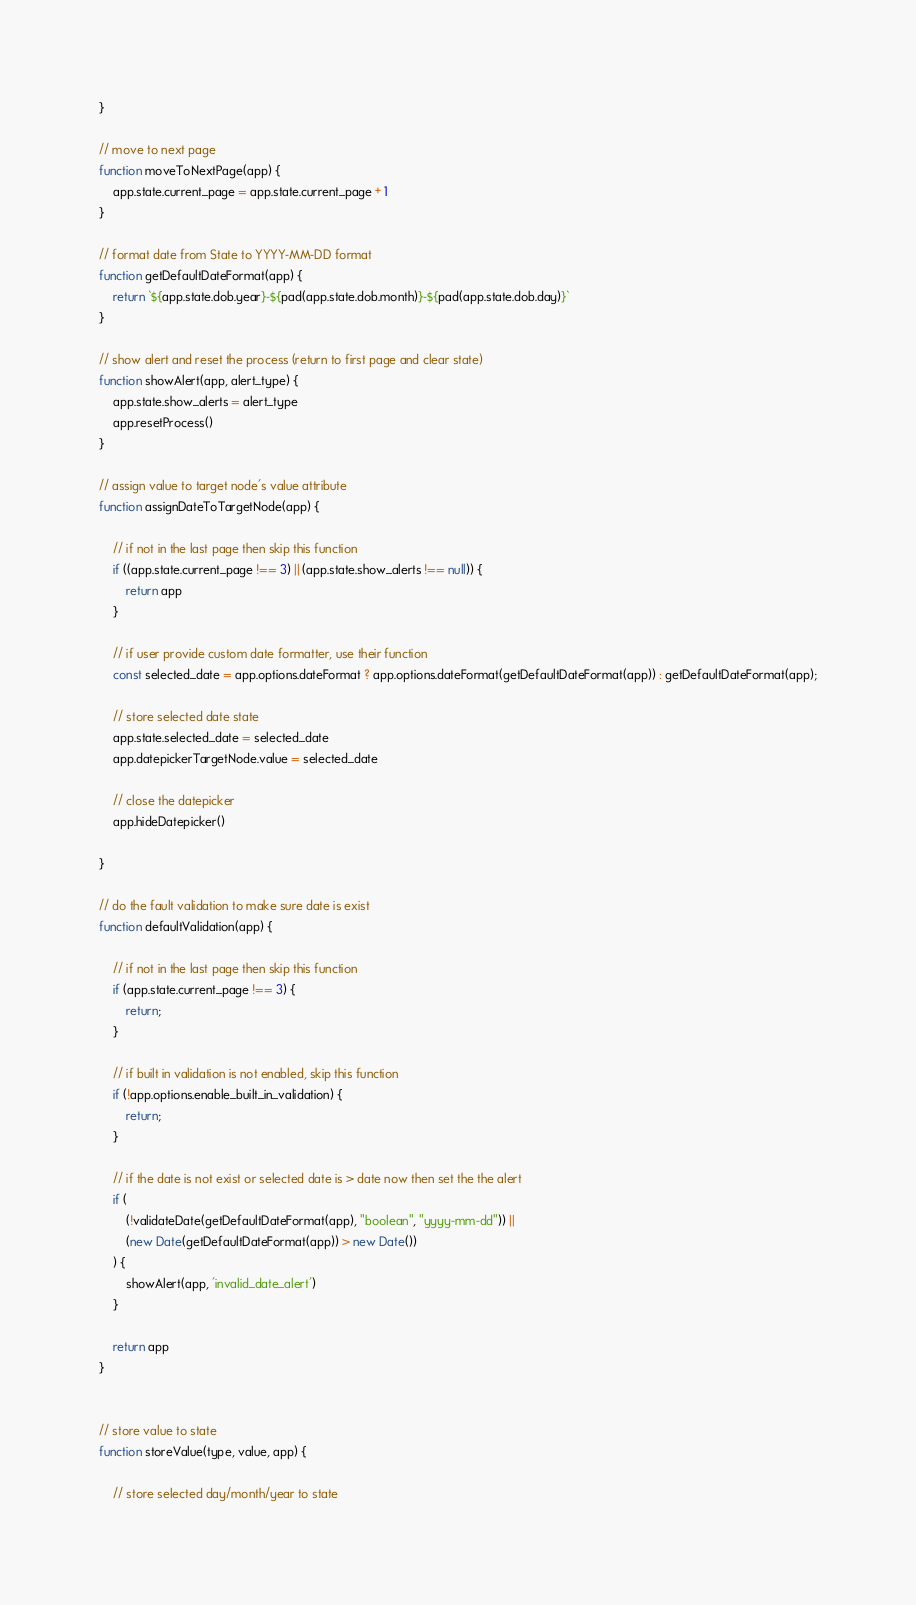<code> <loc_0><loc_0><loc_500><loc_500><_JavaScript_>}

// move to next page
function moveToNextPage(app) {
    app.state.current_page = app.state.current_page + 1
}

// format date from State to YYYY-MM-DD format
function getDefaultDateFormat(app) {
    return `${app.state.dob.year}-${pad(app.state.dob.month)}-${pad(app.state.dob.day)}`
}

// show alert and reset the process (return to first page and clear state)
function showAlert(app, alert_type) {
    app.state.show_alerts = alert_type
    app.resetProcess()
}

// assign value to target node's value attribute
function assignDateToTargetNode(app) {

    // if not in the last page then skip this function
    if ((app.state.current_page !== 3) || (app.state.show_alerts !== null)) {
        return app
    }

    // if user provide custom date formatter, use their function
    const selected_date = app.options.dateFormat ? app.options.dateFormat(getDefaultDateFormat(app)) : getDefaultDateFormat(app);

    // store selected date state
    app.state.selected_date = selected_date
    app.datepickerTargetNode.value = selected_date

    // close the datepicker
    app.hideDatepicker()

}

// do the fault validation to make sure date is exist
function defaultValidation(app) {

    // if not in the last page then skip this function
    if (app.state.current_page !== 3) {
        return;
    }

    // if built in validation is not enabled, skip this function
    if (!app.options.enable_built_in_validation) {
        return;
    }

    // if the date is not exist or selected date is > date now then set the the alert
    if (
        (!validateDate(getDefaultDateFormat(app), "boolean", "yyyy-mm-dd")) ||
        (new Date(getDefaultDateFormat(app)) > new Date())
    ) {
        showAlert(app, 'invalid_date_alert')
    }

    return app
}


// store value to state
function storeValue(type, value, app) {

    // store selected day/month/year to state</code> 